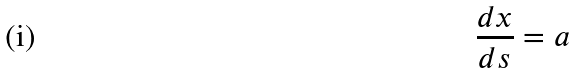Convert formula to latex. <formula><loc_0><loc_0><loc_500><loc_500>\frac { d x } { d s } = a</formula> 